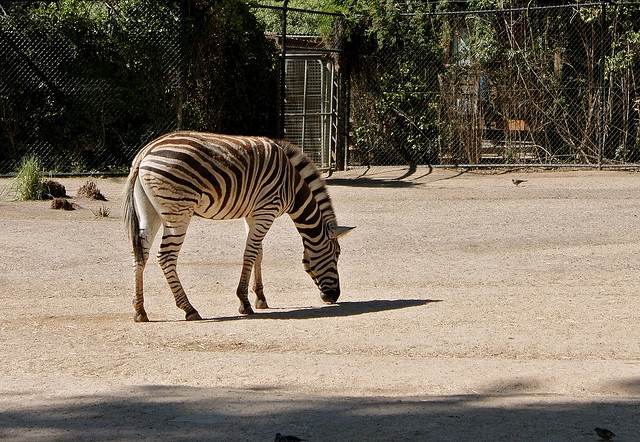Describe the objects in this image and their specific colors. I can see zebra in black, gray, maroon, and tan tones, bench in black and gray tones, bird in black and purple tones, bird in black tones, and bird in black, maroon, and gray tones in this image. 